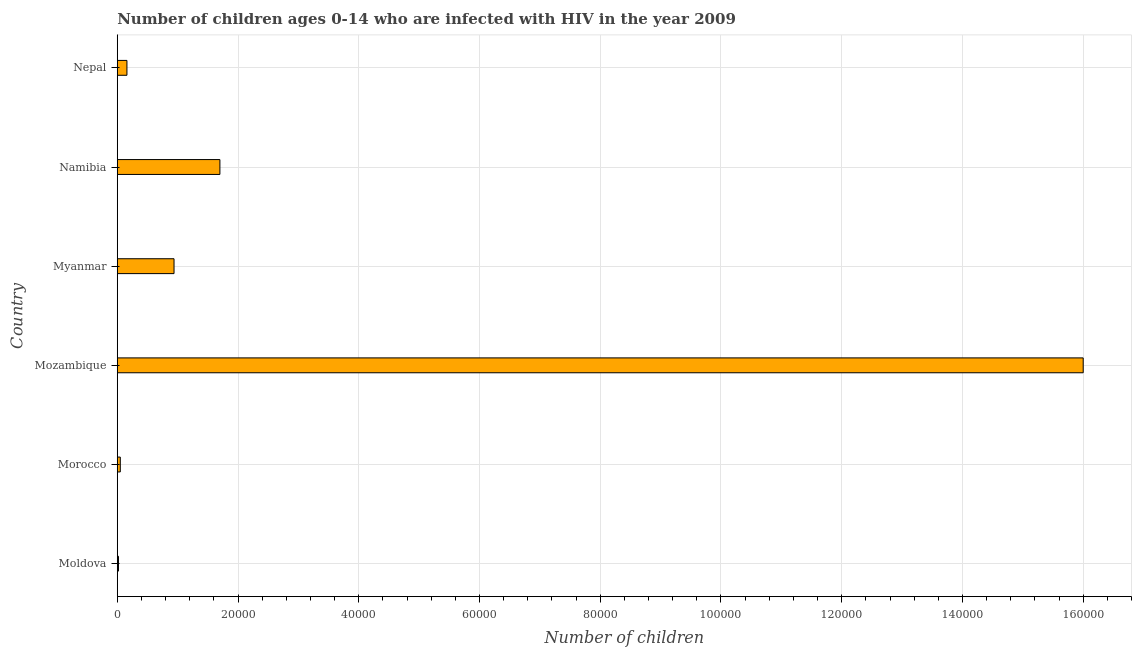Does the graph contain grids?
Give a very brief answer. Yes. What is the title of the graph?
Give a very brief answer. Number of children ages 0-14 who are infected with HIV in the year 2009. What is the label or title of the X-axis?
Your answer should be compact. Number of children. What is the label or title of the Y-axis?
Your response must be concise. Country. Across all countries, what is the maximum number of children living with hiv?
Your answer should be compact. 1.60e+05. Across all countries, what is the minimum number of children living with hiv?
Ensure brevity in your answer.  200. In which country was the number of children living with hiv maximum?
Offer a terse response. Mozambique. In which country was the number of children living with hiv minimum?
Offer a very short reply. Moldova. What is the sum of the number of children living with hiv?
Provide a succinct answer. 1.89e+05. What is the difference between the number of children living with hiv in Moldova and Mozambique?
Your answer should be very brief. -1.60e+05. What is the average number of children living with hiv per country?
Offer a very short reply. 3.14e+04. What is the median number of children living with hiv?
Your answer should be compact. 5500. In how many countries, is the number of children living with hiv greater than 40000 ?
Give a very brief answer. 1. What is the ratio of the number of children living with hiv in Mozambique to that in Nepal?
Make the answer very short. 100. What is the difference between the highest and the second highest number of children living with hiv?
Make the answer very short. 1.43e+05. What is the difference between the highest and the lowest number of children living with hiv?
Offer a terse response. 1.60e+05. In how many countries, is the number of children living with hiv greater than the average number of children living with hiv taken over all countries?
Keep it short and to the point. 1. Are all the bars in the graph horizontal?
Provide a succinct answer. Yes. How many countries are there in the graph?
Give a very brief answer. 6. What is the difference between two consecutive major ticks on the X-axis?
Keep it short and to the point. 2.00e+04. Are the values on the major ticks of X-axis written in scientific E-notation?
Keep it short and to the point. No. What is the Number of children of Mozambique?
Provide a short and direct response. 1.60e+05. What is the Number of children of Myanmar?
Your answer should be compact. 9400. What is the Number of children in Namibia?
Make the answer very short. 1.70e+04. What is the Number of children in Nepal?
Offer a very short reply. 1600. What is the difference between the Number of children in Moldova and Morocco?
Make the answer very short. -300. What is the difference between the Number of children in Moldova and Mozambique?
Give a very brief answer. -1.60e+05. What is the difference between the Number of children in Moldova and Myanmar?
Keep it short and to the point. -9200. What is the difference between the Number of children in Moldova and Namibia?
Give a very brief answer. -1.68e+04. What is the difference between the Number of children in Moldova and Nepal?
Your answer should be compact. -1400. What is the difference between the Number of children in Morocco and Mozambique?
Your answer should be compact. -1.60e+05. What is the difference between the Number of children in Morocco and Myanmar?
Make the answer very short. -8900. What is the difference between the Number of children in Morocco and Namibia?
Make the answer very short. -1.65e+04. What is the difference between the Number of children in Morocco and Nepal?
Offer a terse response. -1100. What is the difference between the Number of children in Mozambique and Myanmar?
Provide a succinct answer. 1.51e+05. What is the difference between the Number of children in Mozambique and Namibia?
Your answer should be very brief. 1.43e+05. What is the difference between the Number of children in Mozambique and Nepal?
Your answer should be compact. 1.58e+05. What is the difference between the Number of children in Myanmar and Namibia?
Keep it short and to the point. -7600. What is the difference between the Number of children in Myanmar and Nepal?
Provide a short and direct response. 7800. What is the difference between the Number of children in Namibia and Nepal?
Ensure brevity in your answer.  1.54e+04. What is the ratio of the Number of children in Moldova to that in Morocco?
Offer a terse response. 0.4. What is the ratio of the Number of children in Moldova to that in Mozambique?
Make the answer very short. 0. What is the ratio of the Number of children in Moldova to that in Myanmar?
Make the answer very short. 0.02. What is the ratio of the Number of children in Moldova to that in Namibia?
Keep it short and to the point. 0.01. What is the ratio of the Number of children in Morocco to that in Mozambique?
Make the answer very short. 0. What is the ratio of the Number of children in Morocco to that in Myanmar?
Your response must be concise. 0.05. What is the ratio of the Number of children in Morocco to that in Namibia?
Make the answer very short. 0.03. What is the ratio of the Number of children in Morocco to that in Nepal?
Your response must be concise. 0.31. What is the ratio of the Number of children in Mozambique to that in Myanmar?
Give a very brief answer. 17.02. What is the ratio of the Number of children in Mozambique to that in Namibia?
Keep it short and to the point. 9.41. What is the ratio of the Number of children in Myanmar to that in Namibia?
Your response must be concise. 0.55. What is the ratio of the Number of children in Myanmar to that in Nepal?
Offer a very short reply. 5.88. What is the ratio of the Number of children in Namibia to that in Nepal?
Give a very brief answer. 10.62. 